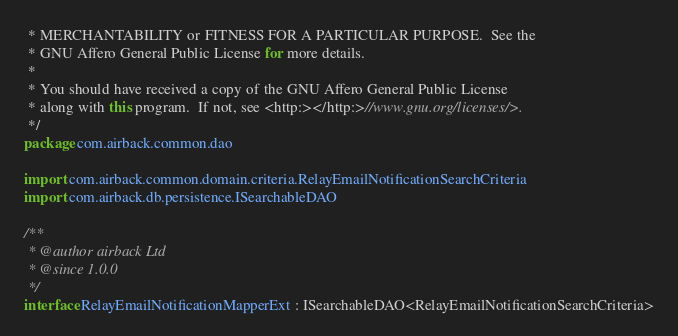Convert code to text. <code><loc_0><loc_0><loc_500><loc_500><_Kotlin_> * MERCHANTABILITY or FITNESS FOR A PARTICULAR PURPOSE.  See the
 * GNU Affero General Public License for more details.
 *
 * You should have received a copy of the GNU Affero General Public License
 * along with this program.  If not, see <http:></http:>//www.gnu.org/licenses/>.
 */
package com.airback.common.dao

import com.airback.common.domain.criteria.RelayEmailNotificationSearchCriteria
import com.airback.db.persistence.ISearchableDAO

/**
 * @author airback Ltd
 * @since 1.0.0
 */
interface RelayEmailNotificationMapperExt : ISearchableDAO<RelayEmailNotificationSearchCriteria>
</code> 